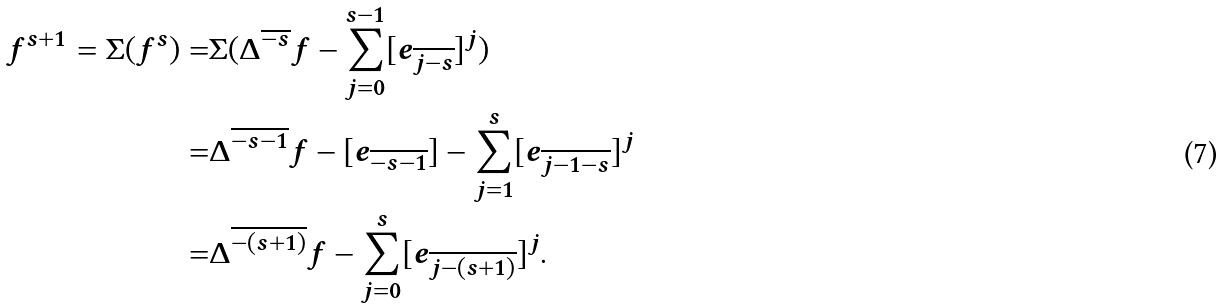Convert formula to latex. <formula><loc_0><loc_0><loc_500><loc_500>f ^ { s + 1 } = \Sigma ( f ^ { s } ) = & \Sigma ( \Delta ^ { \overline { - s } } f - \sum _ { j = 0 } ^ { s - 1 } [ e _ { \overline { j - s } } ] ^ { j } ) \\ = & \Delta ^ { \overline { - s - 1 } } f - [ e _ { \overline { - s - 1 } } ] - \sum _ { j = 1 } ^ { s } [ e _ { \overline { j - 1 - s } } ] ^ { j } \\ = & \Delta ^ { \overline { - ( s + 1 ) } } f - \sum _ { j = 0 } ^ { s } [ e _ { \overline { j - ( s + 1 ) } } ] ^ { j } .</formula> 